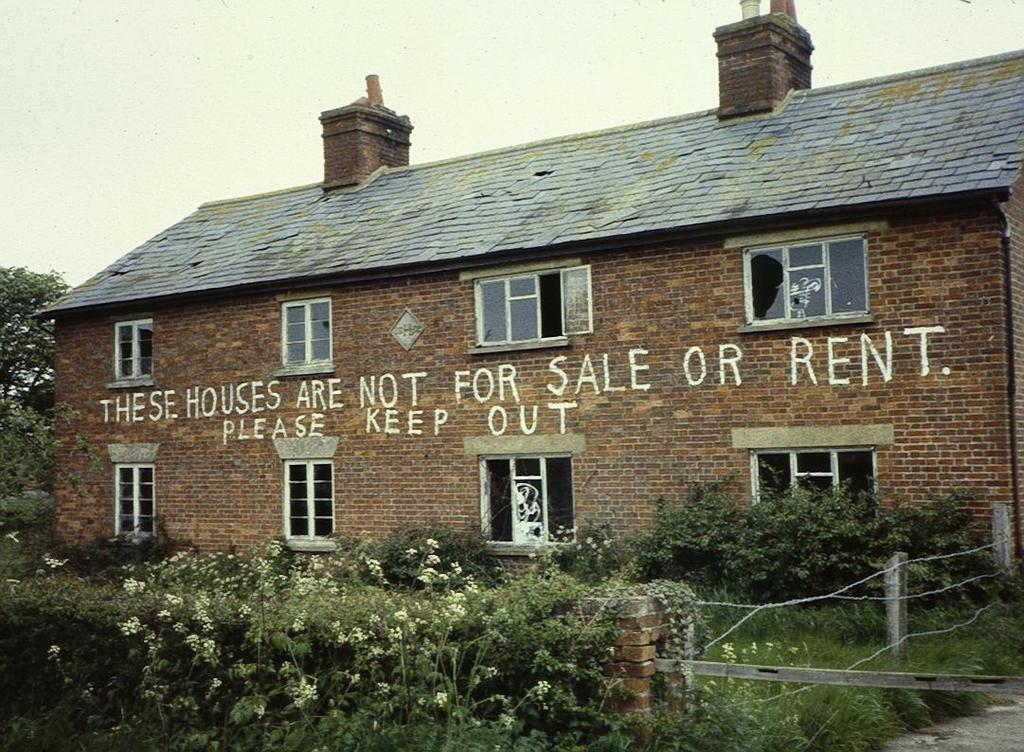What type of structure is present in the image? There is a building in the image. Can you describe any text on the building? There is white color written text on the building. What type of vegetation can be seen in the image? There are trees and plants in the image. What is visible at the top of the image? The sky is visible at the top of the image. What type of toothbrush is hanging from the tree in the image? There is no toothbrush present in the image; it features a building, trees, plants, and text. Can you tell me how many tickets are visible in the image? There are no tickets present in the image. 